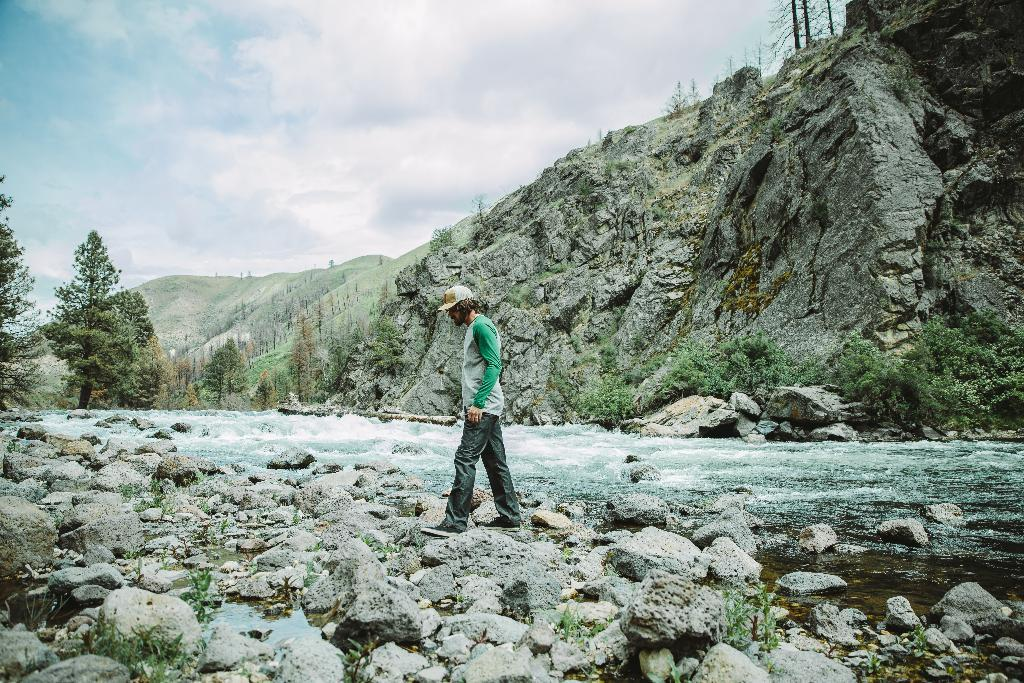What is the man in the image doing? The man is walking in the image. What is the surface on which the man is walking? The man is walking on stones. Where are the stones located? The stones are on the ground. What can be seen in the background of the image? There is water, trees, mountains, rocks, and clouds visible in the background of the image. How does the man plant a seed while walking in the image? There is no seed present in the image, and the man is not shown planting anything while walking. 